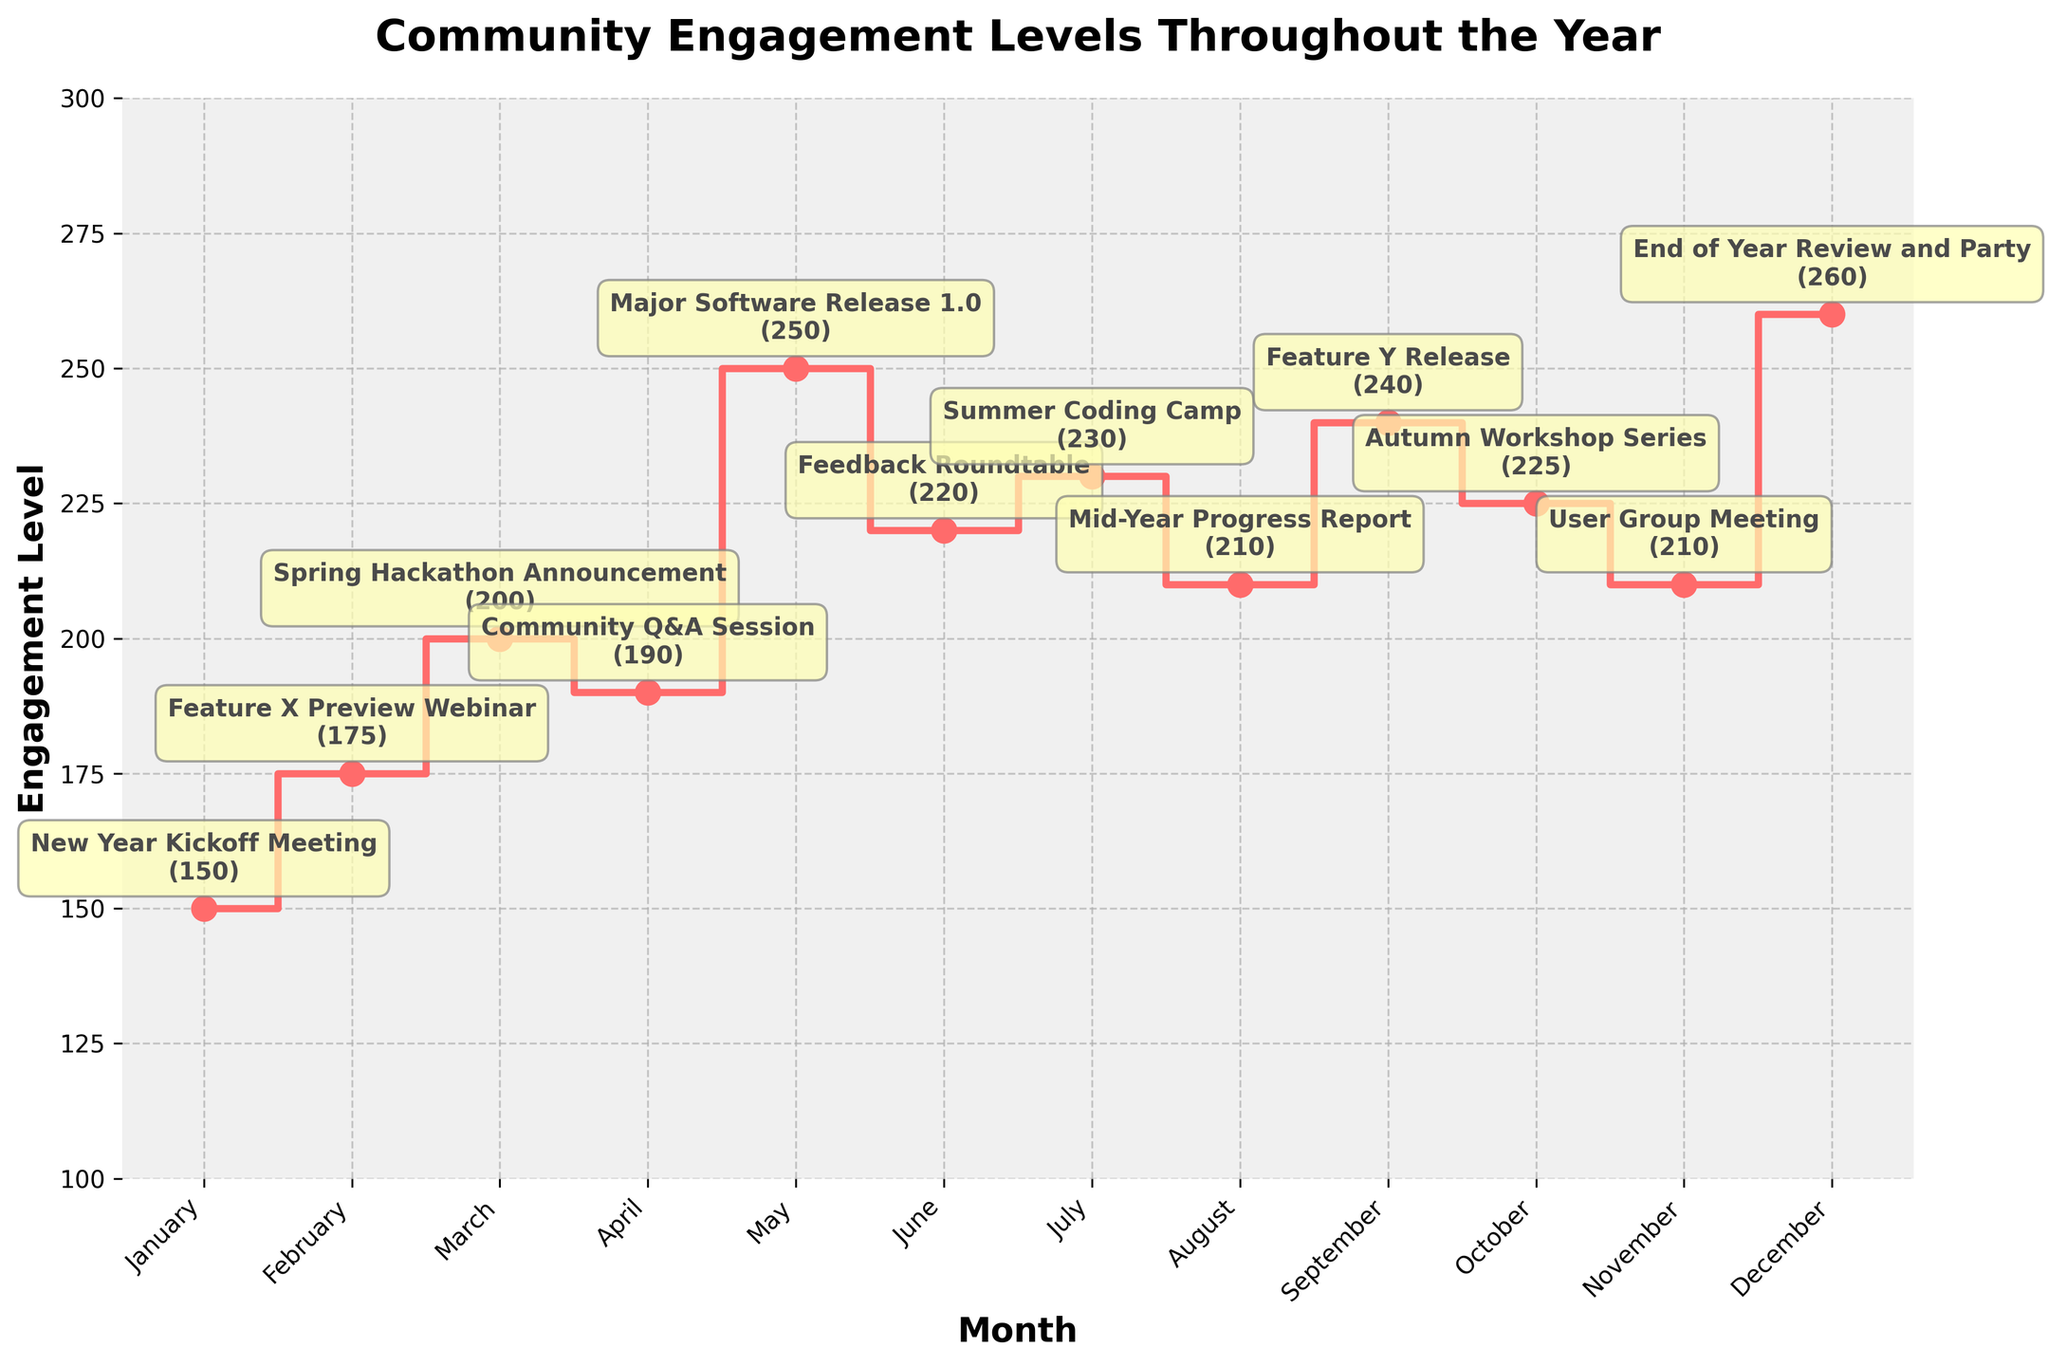What is the title of the figure? The title of the figure is displayed prominently at the top of the chart and provides a summary of what the figure represents. It reads "Community Engagement Levels Throughout the Year."
Answer: Community Engagement Levels Throughout the Year Which month has the highest engagement level? By examining the stair plot, the highest point on the y-axis represents the month with the highest engagement level. December, with the "End of Year Review and Party", reaches an engagement level of 260.
Answer: December How many major events or releases are annotated in the figure? The figure has specific event names annotated above the engagement levels for each month. Counting these annotations from January to December gives a total of 12 major events or releases.
Answer: 12 Which month shows a major software release and what is the engagement level for that month? Referring to the annotated event names, "Major Software Release 1.0" happens in May, and the step for May shows an engagement level of 250.
Answer: May, 250 Which two consecutive months have the largest increase in engagement level? By comparing the heights of the steps between consecutive months, the largest increase is observed between April and May, where the engagement level jumps from 190 to 250, giving an increase of 60.
Answer: April to May What is the average engagement level for the first quarter of the year (January to March)? Adding the engagement levels for January (150), February (175), and March (200) and then dividing by 3, we get: (150 + 175 + 200) / 3 = 525 / 3 = 175.
Answer: 175 Compare the engagement level of March and September, which one is higher and by how much? The engagement levels in March and September are 200 and 240, respectively. September has a higher level by 40 (240 - 200).
Answer: September, 40 What is the general trend in engagement levels from June to December? Observing the steps from June (220) to December (260), the engagement levels trend upwards overall, despite minor fluctuations.
Answer: Upwards How does the engagement level in October compare to that in July? The engagement levels for October and July are 225 and 230, respectively. July's level is slightly higher by 5 (230 - 225).
Answer: July, 5 During which month does the engagement level show a decrease from the previous month? Checking the stair plot, the engagement level decreases from May (250) to June (220), and from July (230) to August (210).
Answer: June, August 